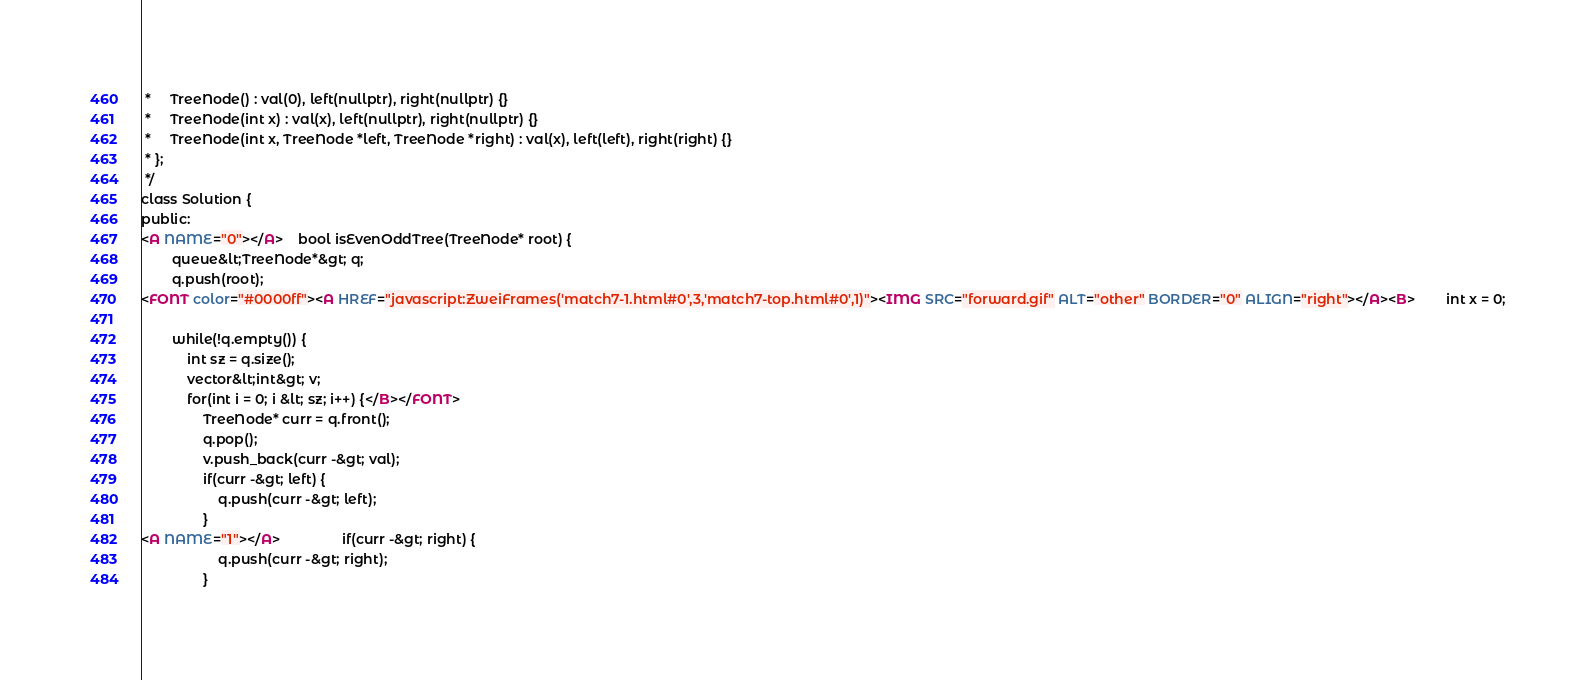Convert code to text. <code><loc_0><loc_0><loc_500><loc_500><_HTML_> *     TreeNode() : val(0), left(nullptr), right(nullptr) {}
 *     TreeNode(int x) : val(x), left(nullptr), right(nullptr) {}
 *     TreeNode(int x, TreeNode *left, TreeNode *right) : val(x), left(left), right(right) {}
 * };
 */
class Solution {
public:
<A NAME="0"></A>    bool isEvenOddTree(TreeNode* root) {
        queue&lt;TreeNode*&gt; q;
        q.push(root);
<FONT color="#0000ff"><A HREF="javascript:ZweiFrames('match7-1.html#0',3,'match7-top.html#0',1)"><IMG SRC="forward.gif" ALT="other" BORDER="0" ALIGN="right"></A><B>        int x = 0;
        
        while(!q.empty()) {
            int sz = q.size();
            vector&lt;int&gt; v;
            for(int i = 0; i &lt; sz; i++) {</B></FONT>
                TreeNode* curr = q.front();
                q.pop();
                v.push_back(curr -&gt; val);
                if(curr -&gt; left) {
                    q.push(curr -&gt; left);
                }
<A NAME="1"></A>                if(curr -&gt; right) {
                    q.push(curr -&gt; right);
                }</code> 